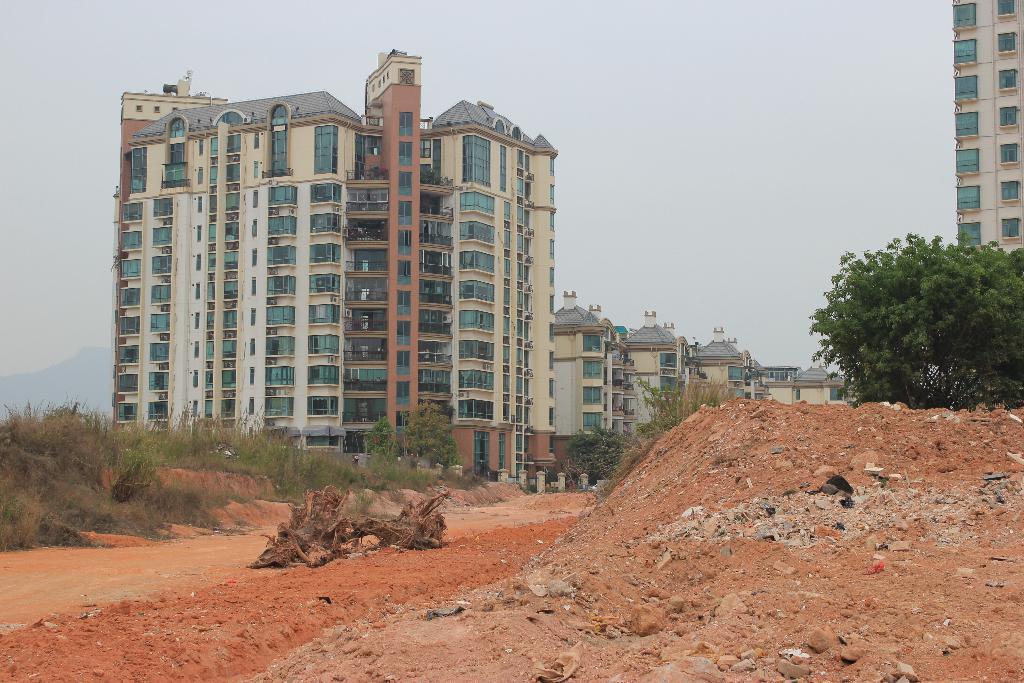Can you describe this image briefly? In the image there are very tall apartments and in front of the apartment there is a lot of empty area filled with sand and on the left side there are many dry plants and on the right side there is a tree. 